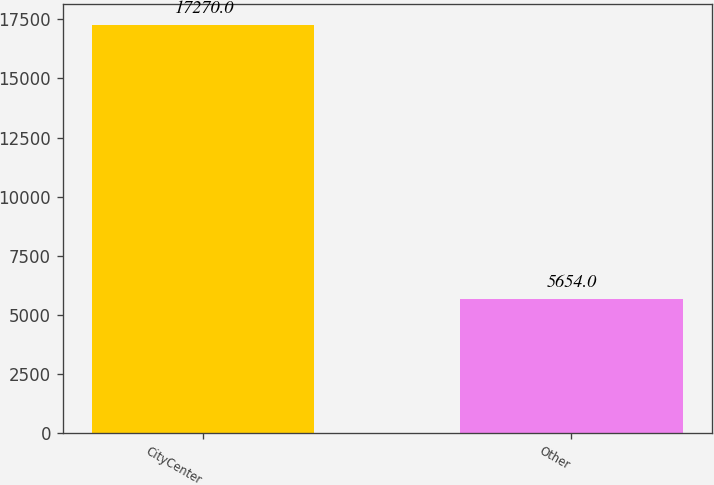<chart> <loc_0><loc_0><loc_500><loc_500><bar_chart><fcel>CityCenter<fcel>Other<nl><fcel>17270<fcel>5654<nl></chart> 